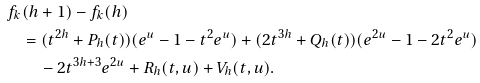<formula> <loc_0><loc_0><loc_500><loc_500>f _ { k } & ( h + 1 ) - f _ { k } ( h ) \\ & = ( t ^ { 2 h } + P _ { h } ( t ) ) ( e ^ { u } - 1 - t ^ { 2 } e ^ { u } ) + ( 2 t ^ { 3 h } + Q _ { h } ( t ) ) ( e ^ { 2 u } - 1 - 2 t ^ { 2 } e ^ { u } ) \\ & \quad - 2 t ^ { 3 h + 3 } e ^ { 2 u } + R _ { h } ( t , u ) + V _ { h } ( t , u ) .</formula> 